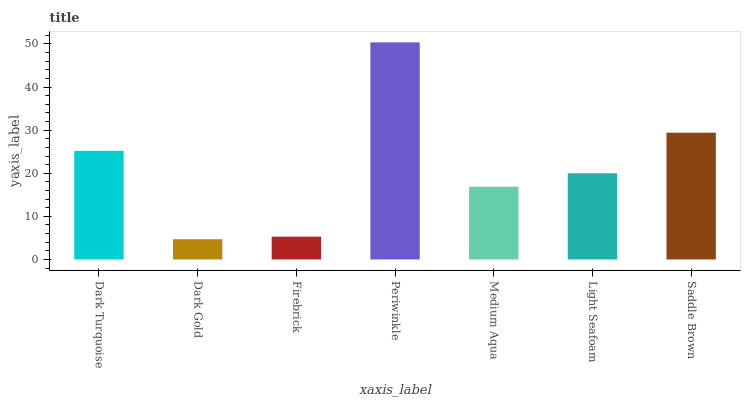Is Dark Gold the minimum?
Answer yes or no. Yes. Is Periwinkle the maximum?
Answer yes or no. Yes. Is Firebrick the minimum?
Answer yes or no. No. Is Firebrick the maximum?
Answer yes or no. No. Is Firebrick greater than Dark Gold?
Answer yes or no. Yes. Is Dark Gold less than Firebrick?
Answer yes or no. Yes. Is Dark Gold greater than Firebrick?
Answer yes or no. No. Is Firebrick less than Dark Gold?
Answer yes or no. No. Is Light Seafoam the high median?
Answer yes or no. Yes. Is Light Seafoam the low median?
Answer yes or no. Yes. Is Firebrick the high median?
Answer yes or no. No. Is Firebrick the low median?
Answer yes or no. No. 